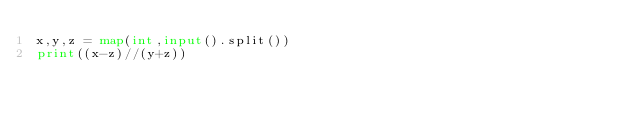<code> <loc_0><loc_0><loc_500><loc_500><_Python_>x,y,z = map(int,input().split())
print((x-z)//(y+z))</code> 